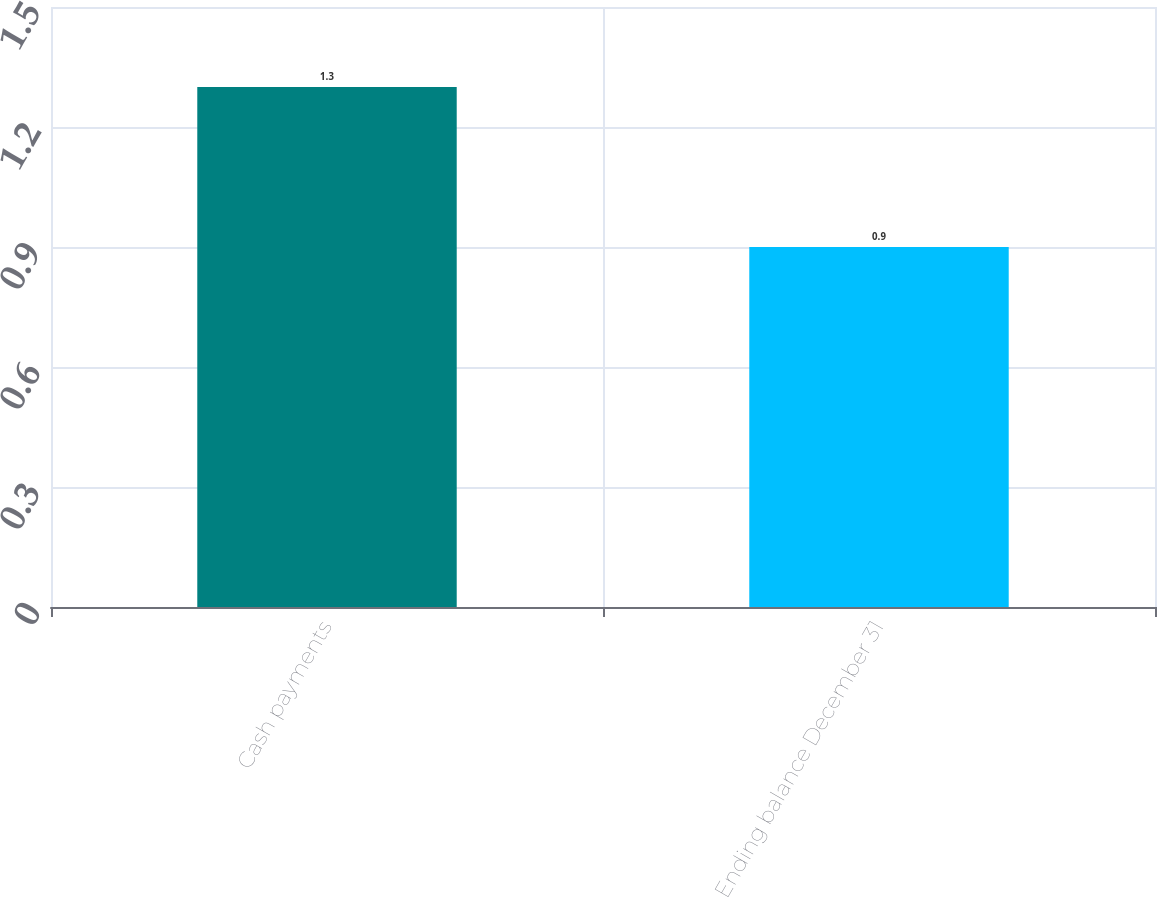Convert chart to OTSL. <chart><loc_0><loc_0><loc_500><loc_500><bar_chart><fcel>Cash payments<fcel>Ending balance December 31<nl><fcel>1.3<fcel>0.9<nl></chart> 